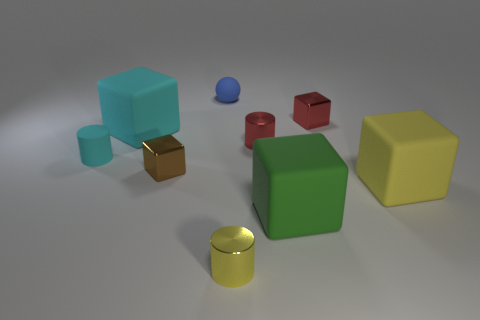Subtract all cyan cubes. How many cubes are left? 4 Subtract 1 cubes. How many cubes are left? 4 Subtract all brown blocks. How many blocks are left? 4 Subtract all blue blocks. Subtract all brown cylinders. How many blocks are left? 5 Add 1 tiny brown cubes. How many objects exist? 10 Subtract all balls. How many objects are left? 8 Add 8 big yellow rubber blocks. How many big yellow rubber blocks are left? 9 Add 2 red metal cylinders. How many red metal cylinders exist? 3 Subtract 0 gray blocks. How many objects are left? 9 Subtract all red things. Subtract all big yellow rubber objects. How many objects are left? 6 